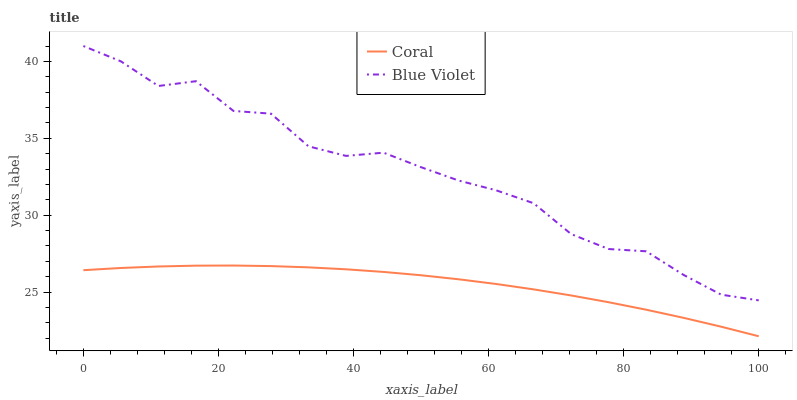Does Blue Violet have the minimum area under the curve?
Answer yes or no. No. Is Blue Violet the smoothest?
Answer yes or no. No. Does Blue Violet have the lowest value?
Answer yes or no. No. Is Coral less than Blue Violet?
Answer yes or no. Yes. Is Blue Violet greater than Coral?
Answer yes or no. Yes. Does Coral intersect Blue Violet?
Answer yes or no. No. 